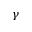<formula> <loc_0><loc_0><loc_500><loc_500>\gamma</formula> 